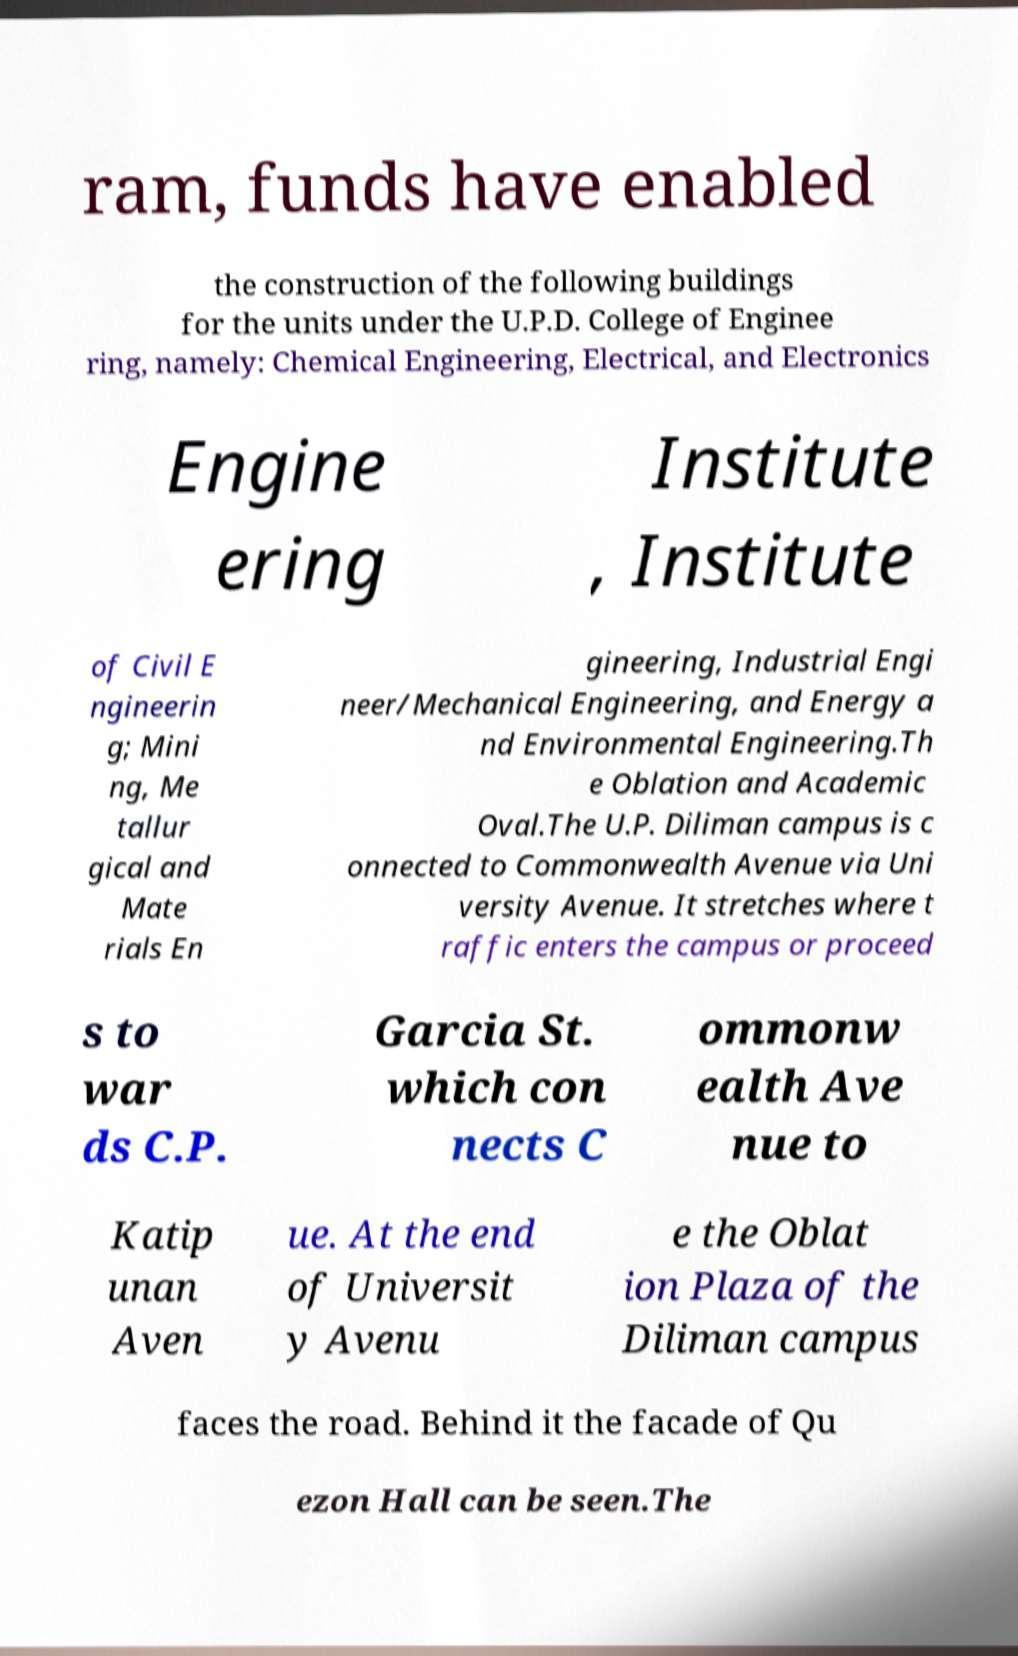What messages or text are displayed in this image? I need them in a readable, typed format. ram, funds have enabled the construction of the following buildings for the units under the U.P.D. College of Enginee ring, namely: Chemical Engineering, Electrical, and Electronics Engine ering Institute , Institute of Civil E ngineerin g; Mini ng, Me tallur gical and Mate rials En gineering, Industrial Engi neer/Mechanical Engineering, and Energy a nd Environmental Engineering.Th e Oblation and Academic Oval.The U.P. Diliman campus is c onnected to Commonwealth Avenue via Uni versity Avenue. It stretches where t raffic enters the campus or proceed s to war ds C.P. Garcia St. which con nects C ommonw ealth Ave nue to Katip unan Aven ue. At the end of Universit y Avenu e the Oblat ion Plaza of the Diliman campus faces the road. Behind it the facade of Qu ezon Hall can be seen.The 